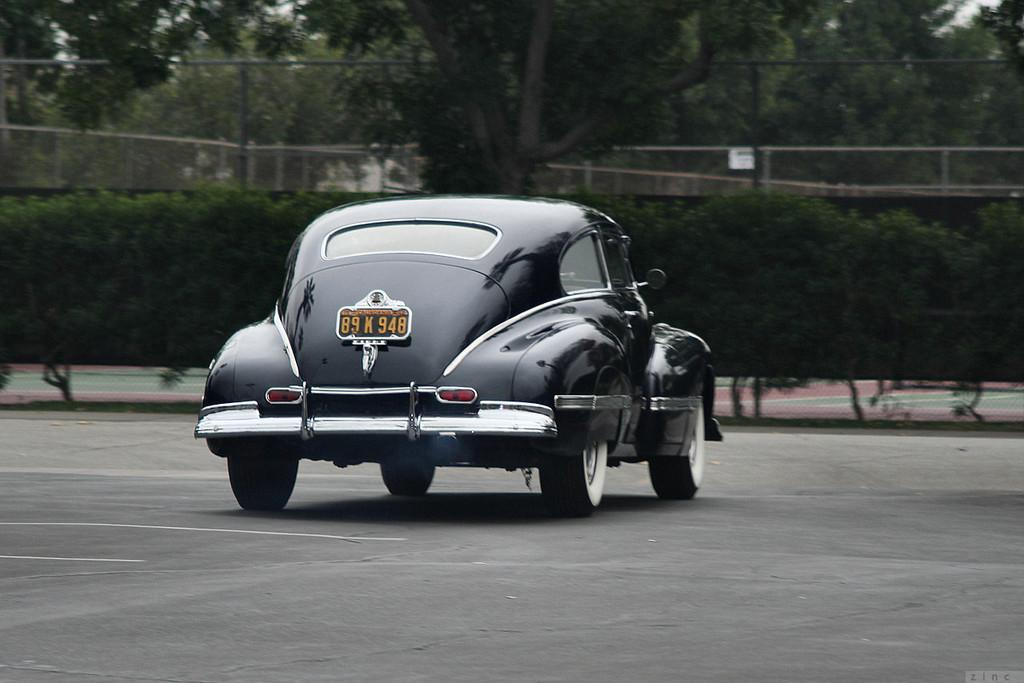What is the main subject in the center of the image? There is a car in the center of the image. Where is the car located? The car is on the road. What can be seen in the background of the image? There are trees visible in the background of the image. What type of toy can be seen walking alongside the car in the image? There is no toy or walking figure present alongside the car in the image. 